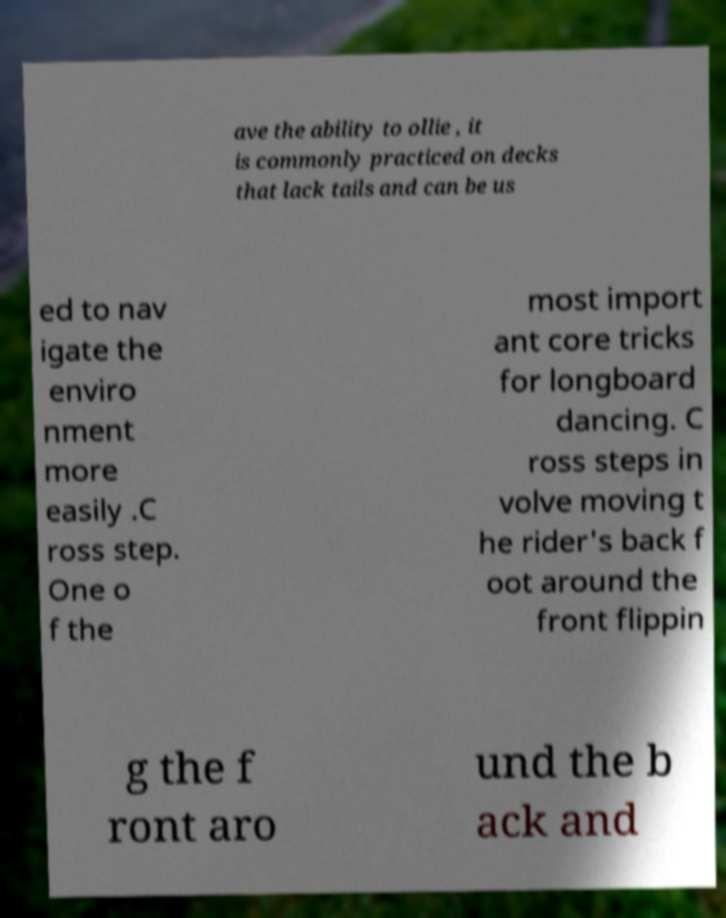Please read and relay the text visible in this image. What does it say? ave the ability to ollie , it is commonly practiced on decks that lack tails and can be us ed to nav igate the enviro nment more easily .C ross step. One o f the most import ant core tricks for longboard dancing. C ross steps in volve moving t he rider's back f oot around the front flippin g the f ront aro und the b ack and 